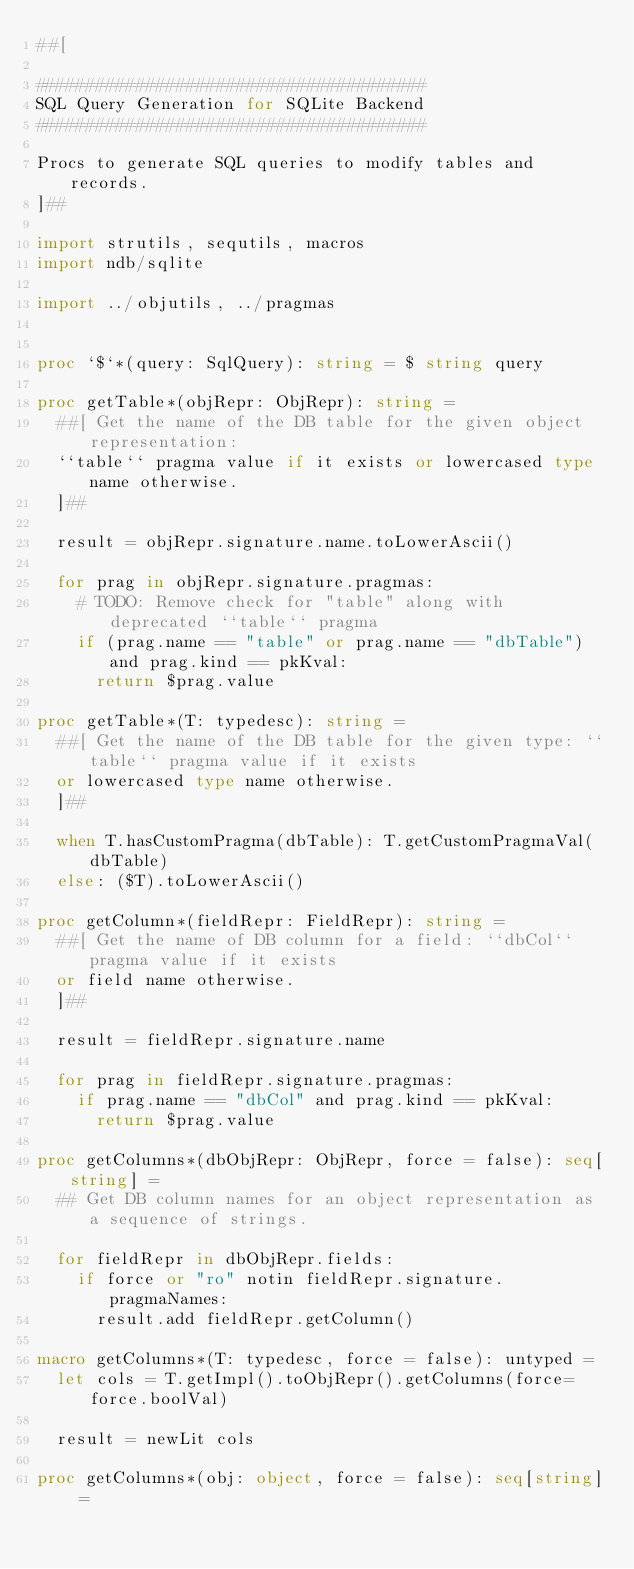Convert code to text. <code><loc_0><loc_0><loc_500><loc_500><_Nim_>##[

#######################################
SQL Query Generation for SQLite Backend
#######################################

Procs to generate SQL queries to modify tables and records.
]##

import strutils, sequtils, macros
import ndb/sqlite

import ../objutils, ../pragmas


proc `$`*(query: SqlQuery): string = $ string query

proc getTable*(objRepr: ObjRepr): string =
  ##[ Get the name of the DB table for the given object representation:
  ``table`` pragma value if it exists or lowercased type name otherwise.
  ]##

  result = objRepr.signature.name.toLowerAscii()

  for prag in objRepr.signature.pragmas:
    # TODO: Remove check for "table" along with deprecated ``table`` pragma
    if (prag.name == "table" or prag.name == "dbTable") and prag.kind == pkKval:
      return $prag.value

proc getTable*(T: typedesc): string =
  ##[ Get the name of the DB table for the given type: ``table`` pragma value if it exists
  or lowercased type name otherwise.
  ]##

  when T.hasCustomPragma(dbTable): T.getCustomPragmaVal(dbTable)
  else: ($T).toLowerAscii()

proc getColumn*(fieldRepr: FieldRepr): string =
  ##[ Get the name of DB column for a field: ``dbCol`` pragma value if it exists
  or field name otherwise.
  ]##

  result = fieldRepr.signature.name

  for prag in fieldRepr.signature.pragmas:
    if prag.name == "dbCol" and prag.kind == pkKval:
      return $prag.value

proc getColumns*(dbObjRepr: ObjRepr, force = false): seq[string] =
  ## Get DB column names for an object representation as a sequence of strings.

  for fieldRepr in dbObjRepr.fields:
    if force or "ro" notin fieldRepr.signature.pragmaNames:
      result.add fieldRepr.getColumn()

macro getColumns*(T: typedesc, force = false): untyped =
  let cols = T.getImpl().toObjRepr().getColumns(force=force.boolVal)

  result = newLit cols

proc getColumns*(obj: object, force = false): seq[string] =</code> 